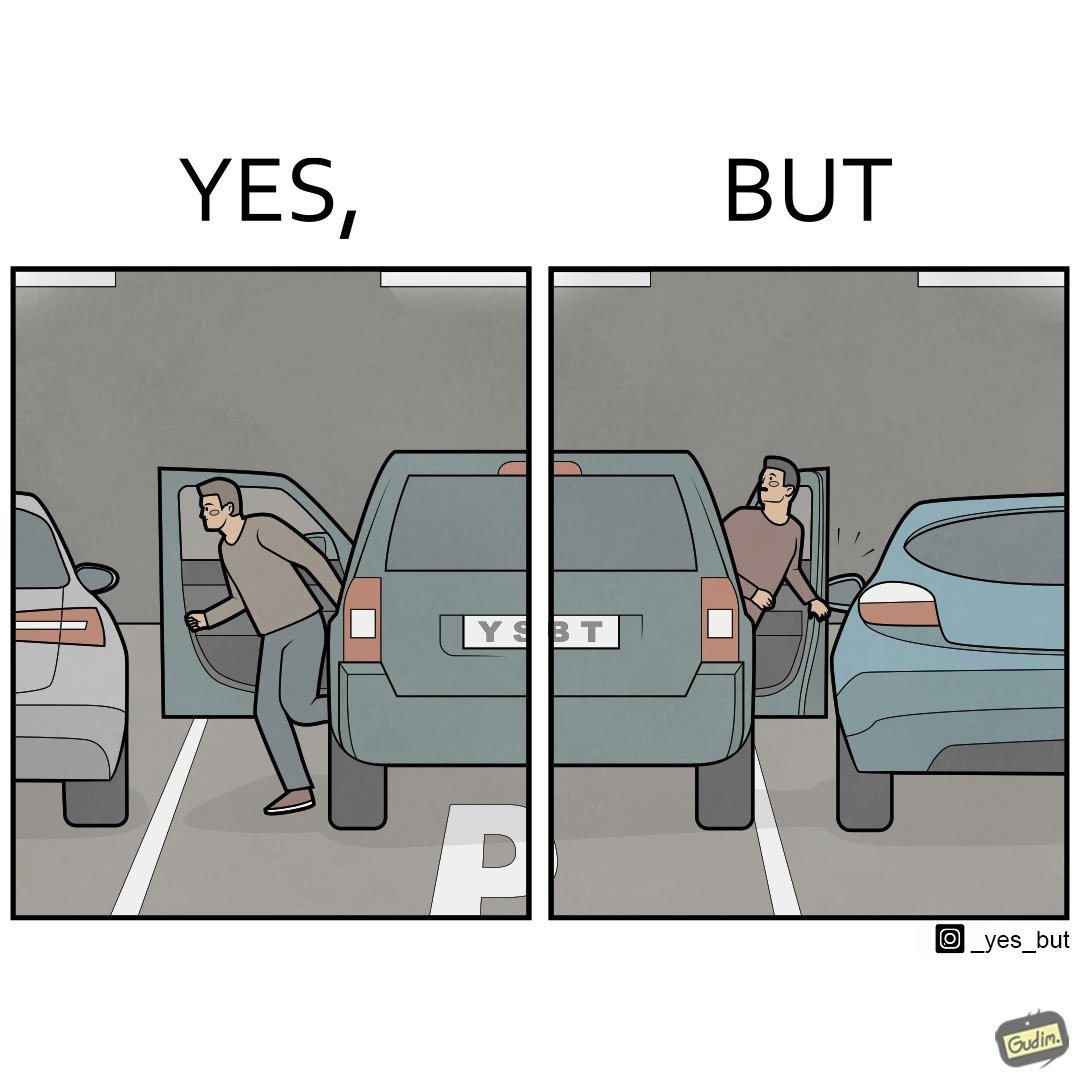What is the satirical meaning behind this image? The image is ironic, because the left door of the car is easily opened with still space left so the car could have been parked more on the left whereas the right door of the car is getting stuck due to the less space between the two cars and the person in facing difficulty in getting himself out but person on the left easily gets out 